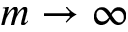Convert formula to latex. <formula><loc_0><loc_0><loc_500><loc_500>m \rightarrow \infty</formula> 